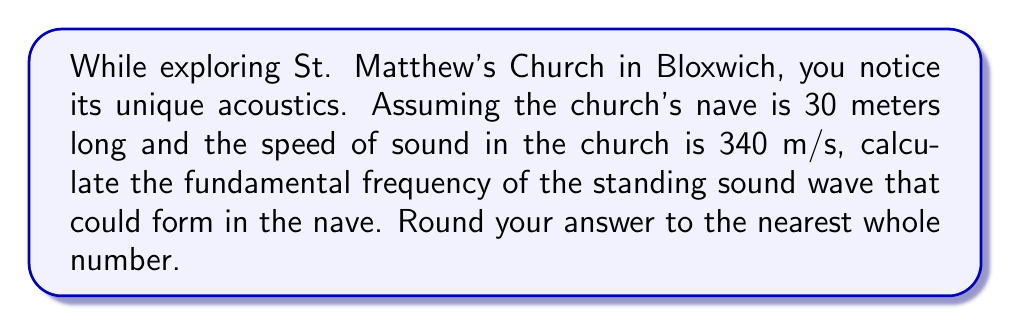Solve this math problem. To solve this problem, we'll use the wave equation for standing waves in a closed tube (which we can approximate the church nave to be). The steps are as follows:

1) The formula for the fundamental frequency of a standing wave in a closed tube is:

   $$f = \frac{v}{2L}$$

   Where:
   $f$ = fundamental frequency (Hz)
   $v$ = speed of sound (m/s)
   $L$ = length of the tube (m)

2) We're given:
   $v = 340$ m/s
   $L = 30$ m

3) Let's substitute these values into our equation:

   $$f = \frac{340}{2(30)}$$

4) Simplify:
   $$f = \frac{340}{60} = 5.6666...$$

5) Rounding to the nearest whole number:
   $$f \approx 6$$

Therefore, the fundamental frequency of the standing sound wave in the nave is approximately 6 Hz.
Answer: 6 Hz 